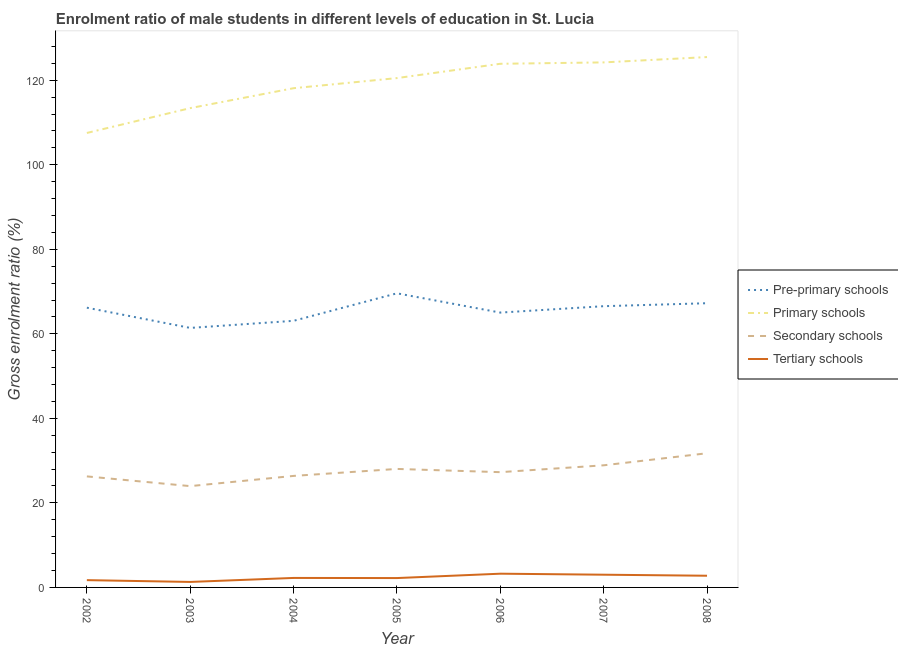Does the line corresponding to gross enrolment ratio(female) in tertiary schools intersect with the line corresponding to gross enrolment ratio(female) in secondary schools?
Your answer should be very brief. No. What is the gross enrolment ratio(female) in pre-primary schools in 2003?
Your answer should be compact. 61.4. Across all years, what is the maximum gross enrolment ratio(female) in primary schools?
Ensure brevity in your answer.  125.48. Across all years, what is the minimum gross enrolment ratio(female) in pre-primary schools?
Your answer should be very brief. 61.4. What is the total gross enrolment ratio(female) in tertiary schools in the graph?
Give a very brief answer. 16.5. What is the difference between the gross enrolment ratio(female) in tertiary schools in 2004 and that in 2006?
Offer a terse response. -1. What is the difference between the gross enrolment ratio(female) in pre-primary schools in 2006 and the gross enrolment ratio(female) in tertiary schools in 2008?
Offer a very short reply. 62.26. What is the average gross enrolment ratio(female) in tertiary schools per year?
Your answer should be very brief. 2.36. In the year 2002, what is the difference between the gross enrolment ratio(female) in secondary schools and gross enrolment ratio(female) in primary schools?
Offer a very short reply. -81.26. In how many years, is the gross enrolment ratio(female) in secondary schools greater than 28 %?
Ensure brevity in your answer.  3. What is the ratio of the gross enrolment ratio(female) in secondary schools in 2005 to that in 2008?
Make the answer very short. 0.88. Is the difference between the gross enrolment ratio(female) in pre-primary schools in 2006 and 2008 greater than the difference between the gross enrolment ratio(female) in tertiary schools in 2006 and 2008?
Your answer should be compact. No. What is the difference between the highest and the second highest gross enrolment ratio(female) in primary schools?
Your response must be concise. 1.26. What is the difference between the highest and the lowest gross enrolment ratio(female) in primary schools?
Your response must be concise. 17.96. Is it the case that in every year, the sum of the gross enrolment ratio(female) in primary schools and gross enrolment ratio(female) in secondary schools is greater than the sum of gross enrolment ratio(female) in pre-primary schools and gross enrolment ratio(female) in tertiary schools?
Give a very brief answer. Yes. Is it the case that in every year, the sum of the gross enrolment ratio(female) in pre-primary schools and gross enrolment ratio(female) in primary schools is greater than the gross enrolment ratio(female) in secondary schools?
Your answer should be very brief. Yes. Does the gross enrolment ratio(female) in tertiary schools monotonically increase over the years?
Your response must be concise. No. Is the gross enrolment ratio(female) in secondary schools strictly greater than the gross enrolment ratio(female) in pre-primary schools over the years?
Your answer should be compact. No. Is the gross enrolment ratio(female) in pre-primary schools strictly less than the gross enrolment ratio(female) in secondary schools over the years?
Make the answer very short. No. What is the difference between two consecutive major ticks on the Y-axis?
Provide a short and direct response. 20. Does the graph contain any zero values?
Give a very brief answer. No. Does the graph contain grids?
Provide a succinct answer. No. How many legend labels are there?
Offer a terse response. 4. How are the legend labels stacked?
Keep it short and to the point. Vertical. What is the title of the graph?
Offer a very short reply. Enrolment ratio of male students in different levels of education in St. Lucia. What is the label or title of the Y-axis?
Your answer should be compact. Gross enrolment ratio (%). What is the Gross enrolment ratio (%) of Pre-primary schools in 2002?
Keep it short and to the point. 66.18. What is the Gross enrolment ratio (%) in Primary schools in 2002?
Your answer should be compact. 107.53. What is the Gross enrolment ratio (%) of Secondary schools in 2002?
Make the answer very short. 26.27. What is the Gross enrolment ratio (%) in Tertiary schools in 2002?
Your response must be concise. 1.72. What is the Gross enrolment ratio (%) in Pre-primary schools in 2003?
Your answer should be very brief. 61.4. What is the Gross enrolment ratio (%) of Primary schools in 2003?
Make the answer very short. 113.4. What is the Gross enrolment ratio (%) in Secondary schools in 2003?
Keep it short and to the point. 23.97. What is the Gross enrolment ratio (%) of Tertiary schools in 2003?
Offer a very short reply. 1.3. What is the Gross enrolment ratio (%) of Pre-primary schools in 2004?
Ensure brevity in your answer.  63.08. What is the Gross enrolment ratio (%) of Primary schools in 2004?
Make the answer very short. 118.12. What is the Gross enrolment ratio (%) in Secondary schools in 2004?
Provide a short and direct response. 26.38. What is the Gross enrolment ratio (%) in Tertiary schools in 2004?
Provide a short and direct response. 2.24. What is the Gross enrolment ratio (%) of Pre-primary schools in 2005?
Keep it short and to the point. 69.59. What is the Gross enrolment ratio (%) of Primary schools in 2005?
Keep it short and to the point. 120.51. What is the Gross enrolment ratio (%) of Secondary schools in 2005?
Provide a succinct answer. 28.04. What is the Gross enrolment ratio (%) in Tertiary schools in 2005?
Ensure brevity in your answer.  2.22. What is the Gross enrolment ratio (%) in Pre-primary schools in 2006?
Offer a terse response. 65.03. What is the Gross enrolment ratio (%) of Primary schools in 2006?
Keep it short and to the point. 123.89. What is the Gross enrolment ratio (%) in Secondary schools in 2006?
Your answer should be very brief. 27.27. What is the Gross enrolment ratio (%) in Tertiary schools in 2006?
Ensure brevity in your answer.  3.25. What is the Gross enrolment ratio (%) of Pre-primary schools in 2007?
Ensure brevity in your answer.  66.54. What is the Gross enrolment ratio (%) in Primary schools in 2007?
Keep it short and to the point. 124.22. What is the Gross enrolment ratio (%) in Secondary schools in 2007?
Your answer should be compact. 28.89. What is the Gross enrolment ratio (%) of Tertiary schools in 2007?
Give a very brief answer. 3.01. What is the Gross enrolment ratio (%) of Pre-primary schools in 2008?
Offer a very short reply. 67.24. What is the Gross enrolment ratio (%) of Primary schools in 2008?
Keep it short and to the point. 125.48. What is the Gross enrolment ratio (%) in Secondary schools in 2008?
Make the answer very short. 31.75. What is the Gross enrolment ratio (%) in Tertiary schools in 2008?
Give a very brief answer. 2.76. Across all years, what is the maximum Gross enrolment ratio (%) in Pre-primary schools?
Keep it short and to the point. 69.59. Across all years, what is the maximum Gross enrolment ratio (%) of Primary schools?
Offer a very short reply. 125.48. Across all years, what is the maximum Gross enrolment ratio (%) in Secondary schools?
Make the answer very short. 31.75. Across all years, what is the maximum Gross enrolment ratio (%) in Tertiary schools?
Ensure brevity in your answer.  3.25. Across all years, what is the minimum Gross enrolment ratio (%) in Pre-primary schools?
Provide a short and direct response. 61.4. Across all years, what is the minimum Gross enrolment ratio (%) of Primary schools?
Provide a short and direct response. 107.53. Across all years, what is the minimum Gross enrolment ratio (%) of Secondary schools?
Provide a succinct answer. 23.97. Across all years, what is the minimum Gross enrolment ratio (%) of Tertiary schools?
Give a very brief answer. 1.3. What is the total Gross enrolment ratio (%) in Pre-primary schools in the graph?
Provide a succinct answer. 459.06. What is the total Gross enrolment ratio (%) of Primary schools in the graph?
Make the answer very short. 833.15. What is the total Gross enrolment ratio (%) of Secondary schools in the graph?
Give a very brief answer. 192.57. What is the total Gross enrolment ratio (%) of Tertiary schools in the graph?
Your answer should be very brief. 16.5. What is the difference between the Gross enrolment ratio (%) in Pre-primary schools in 2002 and that in 2003?
Give a very brief answer. 4.78. What is the difference between the Gross enrolment ratio (%) of Primary schools in 2002 and that in 2003?
Make the answer very short. -5.88. What is the difference between the Gross enrolment ratio (%) of Secondary schools in 2002 and that in 2003?
Keep it short and to the point. 2.3. What is the difference between the Gross enrolment ratio (%) in Tertiary schools in 2002 and that in 2003?
Give a very brief answer. 0.42. What is the difference between the Gross enrolment ratio (%) in Pre-primary schools in 2002 and that in 2004?
Make the answer very short. 3.1. What is the difference between the Gross enrolment ratio (%) of Primary schools in 2002 and that in 2004?
Your answer should be very brief. -10.59. What is the difference between the Gross enrolment ratio (%) of Secondary schools in 2002 and that in 2004?
Make the answer very short. -0.11. What is the difference between the Gross enrolment ratio (%) in Tertiary schools in 2002 and that in 2004?
Your answer should be very brief. -0.52. What is the difference between the Gross enrolment ratio (%) of Pre-primary schools in 2002 and that in 2005?
Ensure brevity in your answer.  -3.4. What is the difference between the Gross enrolment ratio (%) in Primary schools in 2002 and that in 2005?
Offer a very short reply. -12.98. What is the difference between the Gross enrolment ratio (%) in Secondary schools in 2002 and that in 2005?
Make the answer very short. -1.77. What is the difference between the Gross enrolment ratio (%) in Tertiary schools in 2002 and that in 2005?
Give a very brief answer. -0.49. What is the difference between the Gross enrolment ratio (%) of Pre-primary schools in 2002 and that in 2006?
Provide a short and direct response. 1.16. What is the difference between the Gross enrolment ratio (%) in Primary schools in 2002 and that in 2006?
Your answer should be compact. -16.37. What is the difference between the Gross enrolment ratio (%) of Secondary schools in 2002 and that in 2006?
Provide a succinct answer. -1. What is the difference between the Gross enrolment ratio (%) of Tertiary schools in 2002 and that in 2006?
Offer a very short reply. -1.53. What is the difference between the Gross enrolment ratio (%) in Pre-primary schools in 2002 and that in 2007?
Make the answer very short. -0.36. What is the difference between the Gross enrolment ratio (%) in Primary schools in 2002 and that in 2007?
Keep it short and to the point. -16.7. What is the difference between the Gross enrolment ratio (%) of Secondary schools in 2002 and that in 2007?
Your answer should be compact. -2.62. What is the difference between the Gross enrolment ratio (%) of Tertiary schools in 2002 and that in 2007?
Your response must be concise. -1.29. What is the difference between the Gross enrolment ratio (%) of Pre-primary schools in 2002 and that in 2008?
Provide a succinct answer. -1.06. What is the difference between the Gross enrolment ratio (%) of Primary schools in 2002 and that in 2008?
Your response must be concise. -17.96. What is the difference between the Gross enrolment ratio (%) in Secondary schools in 2002 and that in 2008?
Provide a succinct answer. -5.48. What is the difference between the Gross enrolment ratio (%) of Tertiary schools in 2002 and that in 2008?
Your answer should be very brief. -1.04. What is the difference between the Gross enrolment ratio (%) in Pre-primary schools in 2003 and that in 2004?
Offer a terse response. -1.68. What is the difference between the Gross enrolment ratio (%) in Primary schools in 2003 and that in 2004?
Your answer should be very brief. -4.72. What is the difference between the Gross enrolment ratio (%) in Secondary schools in 2003 and that in 2004?
Offer a very short reply. -2.42. What is the difference between the Gross enrolment ratio (%) in Tertiary schools in 2003 and that in 2004?
Provide a succinct answer. -0.95. What is the difference between the Gross enrolment ratio (%) in Pre-primary schools in 2003 and that in 2005?
Your response must be concise. -8.19. What is the difference between the Gross enrolment ratio (%) of Primary schools in 2003 and that in 2005?
Ensure brevity in your answer.  -7.11. What is the difference between the Gross enrolment ratio (%) of Secondary schools in 2003 and that in 2005?
Your response must be concise. -4.07. What is the difference between the Gross enrolment ratio (%) in Tertiary schools in 2003 and that in 2005?
Your answer should be compact. -0.92. What is the difference between the Gross enrolment ratio (%) of Pre-primary schools in 2003 and that in 2006?
Your answer should be compact. -3.63. What is the difference between the Gross enrolment ratio (%) of Primary schools in 2003 and that in 2006?
Offer a very short reply. -10.49. What is the difference between the Gross enrolment ratio (%) in Secondary schools in 2003 and that in 2006?
Ensure brevity in your answer.  -3.3. What is the difference between the Gross enrolment ratio (%) of Tertiary schools in 2003 and that in 2006?
Ensure brevity in your answer.  -1.95. What is the difference between the Gross enrolment ratio (%) in Pre-primary schools in 2003 and that in 2007?
Your response must be concise. -5.14. What is the difference between the Gross enrolment ratio (%) of Primary schools in 2003 and that in 2007?
Provide a succinct answer. -10.82. What is the difference between the Gross enrolment ratio (%) of Secondary schools in 2003 and that in 2007?
Your response must be concise. -4.92. What is the difference between the Gross enrolment ratio (%) in Tertiary schools in 2003 and that in 2007?
Offer a terse response. -1.71. What is the difference between the Gross enrolment ratio (%) of Pre-primary schools in 2003 and that in 2008?
Keep it short and to the point. -5.84. What is the difference between the Gross enrolment ratio (%) of Primary schools in 2003 and that in 2008?
Give a very brief answer. -12.08. What is the difference between the Gross enrolment ratio (%) of Secondary schools in 2003 and that in 2008?
Ensure brevity in your answer.  -7.78. What is the difference between the Gross enrolment ratio (%) in Tertiary schools in 2003 and that in 2008?
Offer a terse response. -1.47. What is the difference between the Gross enrolment ratio (%) in Pre-primary schools in 2004 and that in 2005?
Your response must be concise. -6.51. What is the difference between the Gross enrolment ratio (%) of Primary schools in 2004 and that in 2005?
Make the answer very short. -2.39. What is the difference between the Gross enrolment ratio (%) of Secondary schools in 2004 and that in 2005?
Make the answer very short. -1.65. What is the difference between the Gross enrolment ratio (%) in Tertiary schools in 2004 and that in 2005?
Provide a short and direct response. 0.03. What is the difference between the Gross enrolment ratio (%) of Pre-primary schools in 2004 and that in 2006?
Your answer should be very brief. -1.95. What is the difference between the Gross enrolment ratio (%) in Primary schools in 2004 and that in 2006?
Offer a terse response. -5.78. What is the difference between the Gross enrolment ratio (%) in Secondary schools in 2004 and that in 2006?
Make the answer very short. -0.89. What is the difference between the Gross enrolment ratio (%) of Tertiary schools in 2004 and that in 2006?
Keep it short and to the point. -1. What is the difference between the Gross enrolment ratio (%) of Pre-primary schools in 2004 and that in 2007?
Provide a succinct answer. -3.46. What is the difference between the Gross enrolment ratio (%) of Primary schools in 2004 and that in 2007?
Provide a short and direct response. -6.1. What is the difference between the Gross enrolment ratio (%) in Secondary schools in 2004 and that in 2007?
Your answer should be compact. -2.51. What is the difference between the Gross enrolment ratio (%) in Tertiary schools in 2004 and that in 2007?
Offer a terse response. -0.76. What is the difference between the Gross enrolment ratio (%) in Pre-primary schools in 2004 and that in 2008?
Offer a very short reply. -4.16. What is the difference between the Gross enrolment ratio (%) in Primary schools in 2004 and that in 2008?
Provide a succinct answer. -7.37. What is the difference between the Gross enrolment ratio (%) of Secondary schools in 2004 and that in 2008?
Give a very brief answer. -5.36. What is the difference between the Gross enrolment ratio (%) of Tertiary schools in 2004 and that in 2008?
Ensure brevity in your answer.  -0.52. What is the difference between the Gross enrolment ratio (%) of Pre-primary schools in 2005 and that in 2006?
Your answer should be compact. 4.56. What is the difference between the Gross enrolment ratio (%) of Primary schools in 2005 and that in 2006?
Your answer should be very brief. -3.38. What is the difference between the Gross enrolment ratio (%) of Secondary schools in 2005 and that in 2006?
Keep it short and to the point. 0.76. What is the difference between the Gross enrolment ratio (%) in Tertiary schools in 2005 and that in 2006?
Ensure brevity in your answer.  -1.03. What is the difference between the Gross enrolment ratio (%) of Pre-primary schools in 2005 and that in 2007?
Your answer should be compact. 3.05. What is the difference between the Gross enrolment ratio (%) of Primary schools in 2005 and that in 2007?
Give a very brief answer. -3.71. What is the difference between the Gross enrolment ratio (%) in Secondary schools in 2005 and that in 2007?
Provide a short and direct response. -0.86. What is the difference between the Gross enrolment ratio (%) of Tertiary schools in 2005 and that in 2007?
Your answer should be compact. -0.79. What is the difference between the Gross enrolment ratio (%) of Pre-primary schools in 2005 and that in 2008?
Keep it short and to the point. 2.34. What is the difference between the Gross enrolment ratio (%) of Primary schools in 2005 and that in 2008?
Your answer should be very brief. -4.97. What is the difference between the Gross enrolment ratio (%) of Secondary schools in 2005 and that in 2008?
Ensure brevity in your answer.  -3.71. What is the difference between the Gross enrolment ratio (%) of Tertiary schools in 2005 and that in 2008?
Keep it short and to the point. -0.55. What is the difference between the Gross enrolment ratio (%) of Pre-primary schools in 2006 and that in 2007?
Your response must be concise. -1.51. What is the difference between the Gross enrolment ratio (%) of Primary schools in 2006 and that in 2007?
Your answer should be compact. -0.33. What is the difference between the Gross enrolment ratio (%) in Secondary schools in 2006 and that in 2007?
Your answer should be compact. -1.62. What is the difference between the Gross enrolment ratio (%) of Tertiary schools in 2006 and that in 2007?
Provide a short and direct response. 0.24. What is the difference between the Gross enrolment ratio (%) in Pre-primary schools in 2006 and that in 2008?
Offer a terse response. -2.22. What is the difference between the Gross enrolment ratio (%) in Primary schools in 2006 and that in 2008?
Offer a very short reply. -1.59. What is the difference between the Gross enrolment ratio (%) in Secondary schools in 2006 and that in 2008?
Your answer should be compact. -4.47. What is the difference between the Gross enrolment ratio (%) of Tertiary schools in 2006 and that in 2008?
Make the answer very short. 0.48. What is the difference between the Gross enrolment ratio (%) in Pre-primary schools in 2007 and that in 2008?
Give a very brief answer. -0.7. What is the difference between the Gross enrolment ratio (%) in Primary schools in 2007 and that in 2008?
Your answer should be compact. -1.26. What is the difference between the Gross enrolment ratio (%) of Secondary schools in 2007 and that in 2008?
Your response must be concise. -2.85. What is the difference between the Gross enrolment ratio (%) of Tertiary schools in 2007 and that in 2008?
Provide a short and direct response. 0.24. What is the difference between the Gross enrolment ratio (%) of Pre-primary schools in 2002 and the Gross enrolment ratio (%) of Primary schools in 2003?
Your answer should be very brief. -47.22. What is the difference between the Gross enrolment ratio (%) of Pre-primary schools in 2002 and the Gross enrolment ratio (%) of Secondary schools in 2003?
Your response must be concise. 42.21. What is the difference between the Gross enrolment ratio (%) in Pre-primary schools in 2002 and the Gross enrolment ratio (%) in Tertiary schools in 2003?
Offer a very short reply. 64.88. What is the difference between the Gross enrolment ratio (%) in Primary schools in 2002 and the Gross enrolment ratio (%) in Secondary schools in 2003?
Your answer should be compact. 83.56. What is the difference between the Gross enrolment ratio (%) in Primary schools in 2002 and the Gross enrolment ratio (%) in Tertiary schools in 2003?
Offer a terse response. 106.23. What is the difference between the Gross enrolment ratio (%) of Secondary schools in 2002 and the Gross enrolment ratio (%) of Tertiary schools in 2003?
Your answer should be compact. 24.97. What is the difference between the Gross enrolment ratio (%) of Pre-primary schools in 2002 and the Gross enrolment ratio (%) of Primary schools in 2004?
Provide a succinct answer. -51.93. What is the difference between the Gross enrolment ratio (%) in Pre-primary schools in 2002 and the Gross enrolment ratio (%) in Secondary schools in 2004?
Keep it short and to the point. 39.8. What is the difference between the Gross enrolment ratio (%) in Pre-primary schools in 2002 and the Gross enrolment ratio (%) in Tertiary schools in 2004?
Keep it short and to the point. 63.94. What is the difference between the Gross enrolment ratio (%) in Primary schools in 2002 and the Gross enrolment ratio (%) in Secondary schools in 2004?
Keep it short and to the point. 81.14. What is the difference between the Gross enrolment ratio (%) of Primary schools in 2002 and the Gross enrolment ratio (%) of Tertiary schools in 2004?
Offer a terse response. 105.28. What is the difference between the Gross enrolment ratio (%) in Secondary schools in 2002 and the Gross enrolment ratio (%) in Tertiary schools in 2004?
Keep it short and to the point. 24.03. What is the difference between the Gross enrolment ratio (%) in Pre-primary schools in 2002 and the Gross enrolment ratio (%) in Primary schools in 2005?
Ensure brevity in your answer.  -54.33. What is the difference between the Gross enrolment ratio (%) of Pre-primary schools in 2002 and the Gross enrolment ratio (%) of Secondary schools in 2005?
Give a very brief answer. 38.15. What is the difference between the Gross enrolment ratio (%) of Pre-primary schools in 2002 and the Gross enrolment ratio (%) of Tertiary schools in 2005?
Ensure brevity in your answer.  63.97. What is the difference between the Gross enrolment ratio (%) of Primary schools in 2002 and the Gross enrolment ratio (%) of Secondary schools in 2005?
Your answer should be compact. 79.49. What is the difference between the Gross enrolment ratio (%) in Primary schools in 2002 and the Gross enrolment ratio (%) in Tertiary schools in 2005?
Provide a succinct answer. 105.31. What is the difference between the Gross enrolment ratio (%) in Secondary schools in 2002 and the Gross enrolment ratio (%) in Tertiary schools in 2005?
Keep it short and to the point. 24.05. What is the difference between the Gross enrolment ratio (%) of Pre-primary schools in 2002 and the Gross enrolment ratio (%) of Primary schools in 2006?
Offer a terse response. -57.71. What is the difference between the Gross enrolment ratio (%) in Pre-primary schools in 2002 and the Gross enrolment ratio (%) in Secondary schools in 2006?
Offer a terse response. 38.91. What is the difference between the Gross enrolment ratio (%) of Pre-primary schools in 2002 and the Gross enrolment ratio (%) of Tertiary schools in 2006?
Make the answer very short. 62.93. What is the difference between the Gross enrolment ratio (%) in Primary schools in 2002 and the Gross enrolment ratio (%) in Secondary schools in 2006?
Provide a short and direct response. 80.25. What is the difference between the Gross enrolment ratio (%) of Primary schools in 2002 and the Gross enrolment ratio (%) of Tertiary schools in 2006?
Give a very brief answer. 104.28. What is the difference between the Gross enrolment ratio (%) in Secondary schools in 2002 and the Gross enrolment ratio (%) in Tertiary schools in 2006?
Offer a terse response. 23.02. What is the difference between the Gross enrolment ratio (%) in Pre-primary schools in 2002 and the Gross enrolment ratio (%) in Primary schools in 2007?
Your answer should be compact. -58.04. What is the difference between the Gross enrolment ratio (%) of Pre-primary schools in 2002 and the Gross enrolment ratio (%) of Secondary schools in 2007?
Make the answer very short. 37.29. What is the difference between the Gross enrolment ratio (%) of Pre-primary schools in 2002 and the Gross enrolment ratio (%) of Tertiary schools in 2007?
Ensure brevity in your answer.  63.17. What is the difference between the Gross enrolment ratio (%) of Primary schools in 2002 and the Gross enrolment ratio (%) of Secondary schools in 2007?
Your response must be concise. 78.63. What is the difference between the Gross enrolment ratio (%) in Primary schools in 2002 and the Gross enrolment ratio (%) in Tertiary schools in 2007?
Your answer should be very brief. 104.52. What is the difference between the Gross enrolment ratio (%) of Secondary schools in 2002 and the Gross enrolment ratio (%) of Tertiary schools in 2007?
Your answer should be very brief. 23.26. What is the difference between the Gross enrolment ratio (%) in Pre-primary schools in 2002 and the Gross enrolment ratio (%) in Primary schools in 2008?
Keep it short and to the point. -59.3. What is the difference between the Gross enrolment ratio (%) of Pre-primary schools in 2002 and the Gross enrolment ratio (%) of Secondary schools in 2008?
Your response must be concise. 34.44. What is the difference between the Gross enrolment ratio (%) of Pre-primary schools in 2002 and the Gross enrolment ratio (%) of Tertiary schools in 2008?
Your answer should be compact. 63.42. What is the difference between the Gross enrolment ratio (%) in Primary schools in 2002 and the Gross enrolment ratio (%) in Secondary schools in 2008?
Your answer should be compact. 75.78. What is the difference between the Gross enrolment ratio (%) of Primary schools in 2002 and the Gross enrolment ratio (%) of Tertiary schools in 2008?
Provide a short and direct response. 104.76. What is the difference between the Gross enrolment ratio (%) in Secondary schools in 2002 and the Gross enrolment ratio (%) in Tertiary schools in 2008?
Provide a succinct answer. 23.51. What is the difference between the Gross enrolment ratio (%) of Pre-primary schools in 2003 and the Gross enrolment ratio (%) of Primary schools in 2004?
Keep it short and to the point. -56.72. What is the difference between the Gross enrolment ratio (%) of Pre-primary schools in 2003 and the Gross enrolment ratio (%) of Secondary schools in 2004?
Provide a succinct answer. 35.02. What is the difference between the Gross enrolment ratio (%) of Pre-primary schools in 2003 and the Gross enrolment ratio (%) of Tertiary schools in 2004?
Offer a terse response. 59.16. What is the difference between the Gross enrolment ratio (%) of Primary schools in 2003 and the Gross enrolment ratio (%) of Secondary schools in 2004?
Provide a succinct answer. 87.02. What is the difference between the Gross enrolment ratio (%) in Primary schools in 2003 and the Gross enrolment ratio (%) in Tertiary schools in 2004?
Provide a short and direct response. 111.16. What is the difference between the Gross enrolment ratio (%) in Secondary schools in 2003 and the Gross enrolment ratio (%) in Tertiary schools in 2004?
Ensure brevity in your answer.  21.72. What is the difference between the Gross enrolment ratio (%) in Pre-primary schools in 2003 and the Gross enrolment ratio (%) in Primary schools in 2005?
Offer a terse response. -59.11. What is the difference between the Gross enrolment ratio (%) in Pre-primary schools in 2003 and the Gross enrolment ratio (%) in Secondary schools in 2005?
Make the answer very short. 33.37. What is the difference between the Gross enrolment ratio (%) of Pre-primary schools in 2003 and the Gross enrolment ratio (%) of Tertiary schools in 2005?
Give a very brief answer. 59.19. What is the difference between the Gross enrolment ratio (%) in Primary schools in 2003 and the Gross enrolment ratio (%) in Secondary schools in 2005?
Provide a short and direct response. 85.37. What is the difference between the Gross enrolment ratio (%) of Primary schools in 2003 and the Gross enrolment ratio (%) of Tertiary schools in 2005?
Your response must be concise. 111.19. What is the difference between the Gross enrolment ratio (%) in Secondary schools in 2003 and the Gross enrolment ratio (%) in Tertiary schools in 2005?
Make the answer very short. 21.75. What is the difference between the Gross enrolment ratio (%) of Pre-primary schools in 2003 and the Gross enrolment ratio (%) of Primary schools in 2006?
Give a very brief answer. -62.49. What is the difference between the Gross enrolment ratio (%) in Pre-primary schools in 2003 and the Gross enrolment ratio (%) in Secondary schools in 2006?
Provide a short and direct response. 34.13. What is the difference between the Gross enrolment ratio (%) in Pre-primary schools in 2003 and the Gross enrolment ratio (%) in Tertiary schools in 2006?
Your answer should be very brief. 58.15. What is the difference between the Gross enrolment ratio (%) in Primary schools in 2003 and the Gross enrolment ratio (%) in Secondary schools in 2006?
Provide a succinct answer. 86.13. What is the difference between the Gross enrolment ratio (%) of Primary schools in 2003 and the Gross enrolment ratio (%) of Tertiary schools in 2006?
Provide a succinct answer. 110.15. What is the difference between the Gross enrolment ratio (%) of Secondary schools in 2003 and the Gross enrolment ratio (%) of Tertiary schools in 2006?
Offer a very short reply. 20.72. What is the difference between the Gross enrolment ratio (%) of Pre-primary schools in 2003 and the Gross enrolment ratio (%) of Primary schools in 2007?
Your answer should be compact. -62.82. What is the difference between the Gross enrolment ratio (%) of Pre-primary schools in 2003 and the Gross enrolment ratio (%) of Secondary schools in 2007?
Keep it short and to the point. 32.51. What is the difference between the Gross enrolment ratio (%) of Pre-primary schools in 2003 and the Gross enrolment ratio (%) of Tertiary schools in 2007?
Your response must be concise. 58.39. What is the difference between the Gross enrolment ratio (%) of Primary schools in 2003 and the Gross enrolment ratio (%) of Secondary schools in 2007?
Your answer should be very brief. 84.51. What is the difference between the Gross enrolment ratio (%) in Primary schools in 2003 and the Gross enrolment ratio (%) in Tertiary schools in 2007?
Make the answer very short. 110.39. What is the difference between the Gross enrolment ratio (%) in Secondary schools in 2003 and the Gross enrolment ratio (%) in Tertiary schools in 2007?
Provide a short and direct response. 20.96. What is the difference between the Gross enrolment ratio (%) of Pre-primary schools in 2003 and the Gross enrolment ratio (%) of Primary schools in 2008?
Offer a terse response. -64.08. What is the difference between the Gross enrolment ratio (%) of Pre-primary schools in 2003 and the Gross enrolment ratio (%) of Secondary schools in 2008?
Your response must be concise. 29.65. What is the difference between the Gross enrolment ratio (%) of Pre-primary schools in 2003 and the Gross enrolment ratio (%) of Tertiary schools in 2008?
Make the answer very short. 58.64. What is the difference between the Gross enrolment ratio (%) in Primary schools in 2003 and the Gross enrolment ratio (%) in Secondary schools in 2008?
Provide a short and direct response. 81.65. What is the difference between the Gross enrolment ratio (%) in Primary schools in 2003 and the Gross enrolment ratio (%) in Tertiary schools in 2008?
Provide a short and direct response. 110.64. What is the difference between the Gross enrolment ratio (%) of Secondary schools in 2003 and the Gross enrolment ratio (%) of Tertiary schools in 2008?
Provide a succinct answer. 21.2. What is the difference between the Gross enrolment ratio (%) in Pre-primary schools in 2004 and the Gross enrolment ratio (%) in Primary schools in 2005?
Your answer should be very brief. -57.43. What is the difference between the Gross enrolment ratio (%) of Pre-primary schools in 2004 and the Gross enrolment ratio (%) of Secondary schools in 2005?
Your response must be concise. 35.04. What is the difference between the Gross enrolment ratio (%) of Pre-primary schools in 2004 and the Gross enrolment ratio (%) of Tertiary schools in 2005?
Keep it short and to the point. 60.86. What is the difference between the Gross enrolment ratio (%) in Primary schools in 2004 and the Gross enrolment ratio (%) in Secondary schools in 2005?
Your answer should be compact. 90.08. What is the difference between the Gross enrolment ratio (%) of Primary schools in 2004 and the Gross enrolment ratio (%) of Tertiary schools in 2005?
Offer a terse response. 115.9. What is the difference between the Gross enrolment ratio (%) in Secondary schools in 2004 and the Gross enrolment ratio (%) in Tertiary schools in 2005?
Make the answer very short. 24.17. What is the difference between the Gross enrolment ratio (%) in Pre-primary schools in 2004 and the Gross enrolment ratio (%) in Primary schools in 2006?
Give a very brief answer. -60.81. What is the difference between the Gross enrolment ratio (%) in Pre-primary schools in 2004 and the Gross enrolment ratio (%) in Secondary schools in 2006?
Offer a very short reply. 35.81. What is the difference between the Gross enrolment ratio (%) in Pre-primary schools in 2004 and the Gross enrolment ratio (%) in Tertiary schools in 2006?
Provide a short and direct response. 59.83. What is the difference between the Gross enrolment ratio (%) in Primary schools in 2004 and the Gross enrolment ratio (%) in Secondary schools in 2006?
Your answer should be compact. 90.84. What is the difference between the Gross enrolment ratio (%) of Primary schools in 2004 and the Gross enrolment ratio (%) of Tertiary schools in 2006?
Offer a very short reply. 114.87. What is the difference between the Gross enrolment ratio (%) of Secondary schools in 2004 and the Gross enrolment ratio (%) of Tertiary schools in 2006?
Ensure brevity in your answer.  23.14. What is the difference between the Gross enrolment ratio (%) in Pre-primary schools in 2004 and the Gross enrolment ratio (%) in Primary schools in 2007?
Give a very brief answer. -61.14. What is the difference between the Gross enrolment ratio (%) of Pre-primary schools in 2004 and the Gross enrolment ratio (%) of Secondary schools in 2007?
Your response must be concise. 34.19. What is the difference between the Gross enrolment ratio (%) in Pre-primary schools in 2004 and the Gross enrolment ratio (%) in Tertiary schools in 2007?
Offer a terse response. 60.07. What is the difference between the Gross enrolment ratio (%) of Primary schools in 2004 and the Gross enrolment ratio (%) of Secondary schools in 2007?
Your answer should be compact. 89.22. What is the difference between the Gross enrolment ratio (%) in Primary schools in 2004 and the Gross enrolment ratio (%) in Tertiary schools in 2007?
Your answer should be compact. 115.11. What is the difference between the Gross enrolment ratio (%) of Secondary schools in 2004 and the Gross enrolment ratio (%) of Tertiary schools in 2007?
Your response must be concise. 23.38. What is the difference between the Gross enrolment ratio (%) in Pre-primary schools in 2004 and the Gross enrolment ratio (%) in Primary schools in 2008?
Offer a very short reply. -62.4. What is the difference between the Gross enrolment ratio (%) in Pre-primary schools in 2004 and the Gross enrolment ratio (%) in Secondary schools in 2008?
Your answer should be compact. 31.33. What is the difference between the Gross enrolment ratio (%) in Pre-primary schools in 2004 and the Gross enrolment ratio (%) in Tertiary schools in 2008?
Give a very brief answer. 60.31. What is the difference between the Gross enrolment ratio (%) of Primary schools in 2004 and the Gross enrolment ratio (%) of Secondary schools in 2008?
Make the answer very short. 86.37. What is the difference between the Gross enrolment ratio (%) in Primary schools in 2004 and the Gross enrolment ratio (%) in Tertiary schools in 2008?
Your answer should be compact. 115.35. What is the difference between the Gross enrolment ratio (%) of Secondary schools in 2004 and the Gross enrolment ratio (%) of Tertiary schools in 2008?
Give a very brief answer. 23.62. What is the difference between the Gross enrolment ratio (%) of Pre-primary schools in 2005 and the Gross enrolment ratio (%) of Primary schools in 2006?
Your answer should be very brief. -54.31. What is the difference between the Gross enrolment ratio (%) in Pre-primary schools in 2005 and the Gross enrolment ratio (%) in Secondary schools in 2006?
Offer a terse response. 42.31. What is the difference between the Gross enrolment ratio (%) of Pre-primary schools in 2005 and the Gross enrolment ratio (%) of Tertiary schools in 2006?
Keep it short and to the point. 66.34. What is the difference between the Gross enrolment ratio (%) of Primary schools in 2005 and the Gross enrolment ratio (%) of Secondary schools in 2006?
Keep it short and to the point. 93.24. What is the difference between the Gross enrolment ratio (%) in Primary schools in 2005 and the Gross enrolment ratio (%) in Tertiary schools in 2006?
Ensure brevity in your answer.  117.26. What is the difference between the Gross enrolment ratio (%) in Secondary schools in 2005 and the Gross enrolment ratio (%) in Tertiary schools in 2006?
Give a very brief answer. 24.79. What is the difference between the Gross enrolment ratio (%) in Pre-primary schools in 2005 and the Gross enrolment ratio (%) in Primary schools in 2007?
Provide a short and direct response. -54.63. What is the difference between the Gross enrolment ratio (%) in Pre-primary schools in 2005 and the Gross enrolment ratio (%) in Secondary schools in 2007?
Offer a very short reply. 40.69. What is the difference between the Gross enrolment ratio (%) of Pre-primary schools in 2005 and the Gross enrolment ratio (%) of Tertiary schools in 2007?
Ensure brevity in your answer.  66.58. What is the difference between the Gross enrolment ratio (%) in Primary schools in 2005 and the Gross enrolment ratio (%) in Secondary schools in 2007?
Ensure brevity in your answer.  91.62. What is the difference between the Gross enrolment ratio (%) of Primary schools in 2005 and the Gross enrolment ratio (%) of Tertiary schools in 2007?
Offer a very short reply. 117.5. What is the difference between the Gross enrolment ratio (%) in Secondary schools in 2005 and the Gross enrolment ratio (%) in Tertiary schools in 2007?
Your answer should be very brief. 25.03. What is the difference between the Gross enrolment ratio (%) of Pre-primary schools in 2005 and the Gross enrolment ratio (%) of Primary schools in 2008?
Give a very brief answer. -55.89. What is the difference between the Gross enrolment ratio (%) in Pre-primary schools in 2005 and the Gross enrolment ratio (%) in Secondary schools in 2008?
Offer a very short reply. 37.84. What is the difference between the Gross enrolment ratio (%) in Pre-primary schools in 2005 and the Gross enrolment ratio (%) in Tertiary schools in 2008?
Offer a very short reply. 66.82. What is the difference between the Gross enrolment ratio (%) in Primary schools in 2005 and the Gross enrolment ratio (%) in Secondary schools in 2008?
Your response must be concise. 88.76. What is the difference between the Gross enrolment ratio (%) in Primary schools in 2005 and the Gross enrolment ratio (%) in Tertiary schools in 2008?
Offer a very short reply. 117.74. What is the difference between the Gross enrolment ratio (%) of Secondary schools in 2005 and the Gross enrolment ratio (%) of Tertiary schools in 2008?
Your answer should be very brief. 25.27. What is the difference between the Gross enrolment ratio (%) in Pre-primary schools in 2006 and the Gross enrolment ratio (%) in Primary schools in 2007?
Give a very brief answer. -59.2. What is the difference between the Gross enrolment ratio (%) in Pre-primary schools in 2006 and the Gross enrolment ratio (%) in Secondary schools in 2007?
Ensure brevity in your answer.  36.13. What is the difference between the Gross enrolment ratio (%) in Pre-primary schools in 2006 and the Gross enrolment ratio (%) in Tertiary schools in 2007?
Give a very brief answer. 62.02. What is the difference between the Gross enrolment ratio (%) in Primary schools in 2006 and the Gross enrolment ratio (%) in Secondary schools in 2007?
Offer a terse response. 95. What is the difference between the Gross enrolment ratio (%) of Primary schools in 2006 and the Gross enrolment ratio (%) of Tertiary schools in 2007?
Your answer should be compact. 120.88. What is the difference between the Gross enrolment ratio (%) of Secondary schools in 2006 and the Gross enrolment ratio (%) of Tertiary schools in 2007?
Provide a short and direct response. 24.26. What is the difference between the Gross enrolment ratio (%) of Pre-primary schools in 2006 and the Gross enrolment ratio (%) of Primary schools in 2008?
Ensure brevity in your answer.  -60.46. What is the difference between the Gross enrolment ratio (%) in Pre-primary schools in 2006 and the Gross enrolment ratio (%) in Secondary schools in 2008?
Keep it short and to the point. 33.28. What is the difference between the Gross enrolment ratio (%) of Pre-primary schools in 2006 and the Gross enrolment ratio (%) of Tertiary schools in 2008?
Give a very brief answer. 62.26. What is the difference between the Gross enrolment ratio (%) of Primary schools in 2006 and the Gross enrolment ratio (%) of Secondary schools in 2008?
Ensure brevity in your answer.  92.15. What is the difference between the Gross enrolment ratio (%) of Primary schools in 2006 and the Gross enrolment ratio (%) of Tertiary schools in 2008?
Keep it short and to the point. 121.13. What is the difference between the Gross enrolment ratio (%) of Secondary schools in 2006 and the Gross enrolment ratio (%) of Tertiary schools in 2008?
Provide a short and direct response. 24.51. What is the difference between the Gross enrolment ratio (%) of Pre-primary schools in 2007 and the Gross enrolment ratio (%) of Primary schools in 2008?
Offer a terse response. -58.94. What is the difference between the Gross enrolment ratio (%) in Pre-primary schools in 2007 and the Gross enrolment ratio (%) in Secondary schools in 2008?
Provide a succinct answer. 34.79. What is the difference between the Gross enrolment ratio (%) of Pre-primary schools in 2007 and the Gross enrolment ratio (%) of Tertiary schools in 2008?
Make the answer very short. 63.77. What is the difference between the Gross enrolment ratio (%) in Primary schools in 2007 and the Gross enrolment ratio (%) in Secondary schools in 2008?
Your answer should be very brief. 92.47. What is the difference between the Gross enrolment ratio (%) of Primary schools in 2007 and the Gross enrolment ratio (%) of Tertiary schools in 2008?
Offer a terse response. 121.46. What is the difference between the Gross enrolment ratio (%) of Secondary schools in 2007 and the Gross enrolment ratio (%) of Tertiary schools in 2008?
Keep it short and to the point. 26.13. What is the average Gross enrolment ratio (%) in Pre-primary schools per year?
Give a very brief answer. 65.58. What is the average Gross enrolment ratio (%) of Primary schools per year?
Provide a short and direct response. 119.02. What is the average Gross enrolment ratio (%) in Secondary schools per year?
Make the answer very short. 27.51. What is the average Gross enrolment ratio (%) of Tertiary schools per year?
Offer a terse response. 2.36. In the year 2002, what is the difference between the Gross enrolment ratio (%) of Pre-primary schools and Gross enrolment ratio (%) of Primary schools?
Keep it short and to the point. -41.34. In the year 2002, what is the difference between the Gross enrolment ratio (%) of Pre-primary schools and Gross enrolment ratio (%) of Secondary schools?
Your answer should be very brief. 39.91. In the year 2002, what is the difference between the Gross enrolment ratio (%) of Pre-primary schools and Gross enrolment ratio (%) of Tertiary schools?
Provide a succinct answer. 64.46. In the year 2002, what is the difference between the Gross enrolment ratio (%) in Primary schools and Gross enrolment ratio (%) in Secondary schools?
Keep it short and to the point. 81.26. In the year 2002, what is the difference between the Gross enrolment ratio (%) in Primary schools and Gross enrolment ratio (%) in Tertiary schools?
Your answer should be compact. 105.8. In the year 2002, what is the difference between the Gross enrolment ratio (%) in Secondary schools and Gross enrolment ratio (%) in Tertiary schools?
Your response must be concise. 24.55. In the year 2003, what is the difference between the Gross enrolment ratio (%) of Pre-primary schools and Gross enrolment ratio (%) of Primary schools?
Provide a short and direct response. -52. In the year 2003, what is the difference between the Gross enrolment ratio (%) of Pre-primary schools and Gross enrolment ratio (%) of Secondary schools?
Keep it short and to the point. 37.43. In the year 2003, what is the difference between the Gross enrolment ratio (%) of Pre-primary schools and Gross enrolment ratio (%) of Tertiary schools?
Your answer should be very brief. 60.1. In the year 2003, what is the difference between the Gross enrolment ratio (%) in Primary schools and Gross enrolment ratio (%) in Secondary schools?
Offer a terse response. 89.43. In the year 2003, what is the difference between the Gross enrolment ratio (%) in Primary schools and Gross enrolment ratio (%) in Tertiary schools?
Provide a short and direct response. 112.1. In the year 2003, what is the difference between the Gross enrolment ratio (%) in Secondary schools and Gross enrolment ratio (%) in Tertiary schools?
Your answer should be very brief. 22.67. In the year 2004, what is the difference between the Gross enrolment ratio (%) in Pre-primary schools and Gross enrolment ratio (%) in Primary schools?
Make the answer very short. -55.04. In the year 2004, what is the difference between the Gross enrolment ratio (%) of Pre-primary schools and Gross enrolment ratio (%) of Secondary schools?
Make the answer very short. 36.69. In the year 2004, what is the difference between the Gross enrolment ratio (%) in Pre-primary schools and Gross enrolment ratio (%) in Tertiary schools?
Offer a very short reply. 60.83. In the year 2004, what is the difference between the Gross enrolment ratio (%) of Primary schools and Gross enrolment ratio (%) of Secondary schools?
Provide a short and direct response. 91.73. In the year 2004, what is the difference between the Gross enrolment ratio (%) of Primary schools and Gross enrolment ratio (%) of Tertiary schools?
Give a very brief answer. 115.87. In the year 2004, what is the difference between the Gross enrolment ratio (%) in Secondary schools and Gross enrolment ratio (%) in Tertiary schools?
Ensure brevity in your answer.  24.14. In the year 2005, what is the difference between the Gross enrolment ratio (%) in Pre-primary schools and Gross enrolment ratio (%) in Primary schools?
Keep it short and to the point. -50.92. In the year 2005, what is the difference between the Gross enrolment ratio (%) of Pre-primary schools and Gross enrolment ratio (%) of Secondary schools?
Keep it short and to the point. 41.55. In the year 2005, what is the difference between the Gross enrolment ratio (%) of Pre-primary schools and Gross enrolment ratio (%) of Tertiary schools?
Give a very brief answer. 67.37. In the year 2005, what is the difference between the Gross enrolment ratio (%) of Primary schools and Gross enrolment ratio (%) of Secondary schools?
Offer a very short reply. 92.47. In the year 2005, what is the difference between the Gross enrolment ratio (%) in Primary schools and Gross enrolment ratio (%) in Tertiary schools?
Keep it short and to the point. 118.29. In the year 2005, what is the difference between the Gross enrolment ratio (%) of Secondary schools and Gross enrolment ratio (%) of Tertiary schools?
Keep it short and to the point. 25.82. In the year 2006, what is the difference between the Gross enrolment ratio (%) in Pre-primary schools and Gross enrolment ratio (%) in Primary schools?
Offer a terse response. -58.87. In the year 2006, what is the difference between the Gross enrolment ratio (%) of Pre-primary schools and Gross enrolment ratio (%) of Secondary schools?
Keep it short and to the point. 37.75. In the year 2006, what is the difference between the Gross enrolment ratio (%) of Pre-primary schools and Gross enrolment ratio (%) of Tertiary schools?
Ensure brevity in your answer.  61.78. In the year 2006, what is the difference between the Gross enrolment ratio (%) of Primary schools and Gross enrolment ratio (%) of Secondary schools?
Make the answer very short. 96.62. In the year 2006, what is the difference between the Gross enrolment ratio (%) in Primary schools and Gross enrolment ratio (%) in Tertiary schools?
Your answer should be very brief. 120.64. In the year 2006, what is the difference between the Gross enrolment ratio (%) in Secondary schools and Gross enrolment ratio (%) in Tertiary schools?
Keep it short and to the point. 24.02. In the year 2007, what is the difference between the Gross enrolment ratio (%) of Pre-primary schools and Gross enrolment ratio (%) of Primary schools?
Offer a very short reply. -57.68. In the year 2007, what is the difference between the Gross enrolment ratio (%) in Pre-primary schools and Gross enrolment ratio (%) in Secondary schools?
Your response must be concise. 37.65. In the year 2007, what is the difference between the Gross enrolment ratio (%) of Pre-primary schools and Gross enrolment ratio (%) of Tertiary schools?
Provide a short and direct response. 63.53. In the year 2007, what is the difference between the Gross enrolment ratio (%) of Primary schools and Gross enrolment ratio (%) of Secondary schools?
Make the answer very short. 95.33. In the year 2007, what is the difference between the Gross enrolment ratio (%) of Primary schools and Gross enrolment ratio (%) of Tertiary schools?
Your answer should be very brief. 121.21. In the year 2007, what is the difference between the Gross enrolment ratio (%) of Secondary schools and Gross enrolment ratio (%) of Tertiary schools?
Ensure brevity in your answer.  25.88. In the year 2008, what is the difference between the Gross enrolment ratio (%) of Pre-primary schools and Gross enrolment ratio (%) of Primary schools?
Make the answer very short. -58.24. In the year 2008, what is the difference between the Gross enrolment ratio (%) in Pre-primary schools and Gross enrolment ratio (%) in Secondary schools?
Make the answer very short. 35.5. In the year 2008, what is the difference between the Gross enrolment ratio (%) in Pre-primary schools and Gross enrolment ratio (%) in Tertiary schools?
Offer a terse response. 64.48. In the year 2008, what is the difference between the Gross enrolment ratio (%) in Primary schools and Gross enrolment ratio (%) in Secondary schools?
Your response must be concise. 93.74. In the year 2008, what is the difference between the Gross enrolment ratio (%) in Primary schools and Gross enrolment ratio (%) in Tertiary schools?
Keep it short and to the point. 122.72. In the year 2008, what is the difference between the Gross enrolment ratio (%) of Secondary schools and Gross enrolment ratio (%) of Tertiary schools?
Provide a succinct answer. 28.98. What is the ratio of the Gross enrolment ratio (%) in Pre-primary schools in 2002 to that in 2003?
Your answer should be compact. 1.08. What is the ratio of the Gross enrolment ratio (%) of Primary schools in 2002 to that in 2003?
Give a very brief answer. 0.95. What is the ratio of the Gross enrolment ratio (%) in Secondary schools in 2002 to that in 2003?
Your response must be concise. 1.1. What is the ratio of the Gross enrolment ratio (%) in Tertiary schools in 2002 to that in 2003?
Provide a short and direct response. 1.33. What is the ratio of the Gross enrolment ratio (%) of Pre-primary schools in 2002 to that in 2004?
Offer a very short reply. 1.05. What is the ratio of the Gross enrolment ratio (%) in Primary schools in 2002 to that in 2004?
Provide a succinct answer. 0.91. What is the ratio of the Gross enrolment ratio (%) in Tertiary schools in 2002 to that in 2004?
Ensure brevity in your answer.  0.77. What is the ratio of the Gross enrolment ratio (%) of Pre-primary schools in 2002 to that in 2005?
Make the answer very short. 0.95. What is the ratio of the Gross enrolment ratio (%) of Primary schools in 2002 to that in 2005?
Your response must be concise. 0.89. What is the ratio of the Gross enrolment ratio (%) of Secondary schools in 2002 to that in 2005?
Your response must be concise. 0.94. What is the ratio of the Gross enrolment ratio (%) in Tertiary schools in 2002 to that in 2005?
Keep it short and to the point. 0.78. What is the ratio of the Gross enrolment ratio (%) in Pre-primary schools in 2002 to that in 2006?
Your response must be concise. 1.02. What is the ratio of the Gross enrolment ratio (%) of Primary schools in 2002 to that in 2006?
Your answer should be compact. 0.87. What is the ratio of the Gross enrolment ratio (%) in Secondary schools in 2002 to that in 2006?
Give a very brief answer. 0.96. What is the ratio of the Gross enrolment ratio (%) of Tertiary schools in 2002 to that in 2006?
Offer a very short reply. 0.53. What is the ratio of the Gross enrolment ratio (%) of Pre-primary schools in 2002 to that in 2007?
Offer a very short reply. 0.99. What is the ratio of the Gross enrolment ratio (%) in Primary schools in 2002 to that in 2007?
Give a very brief answer. 0.87. What is the ratio of the Gross enrolment ratio (%) of Secondary schools in 2002 to that in 2007?
Provide a succinct answer. 0.91. What is the ratio of the Gross enrolment ratio (%) of Tertiary schools in 2002 to that in 2007?
Provide a succinct answer. 0.57. What is the ratio of the Gross enrolment ratio (%) in Pre-primary schools in 2002 to that in 2008?
Make the answer very short. 0.98. What is the ratio of the Gross enrolment ratio (%) of Primary schools in 2002 to that in 2008?
Offer a terse response. 0.86. What is the ratio of the Gross enrolment ratio (%) in Secondary schools in 2002 to that in 2008?
Keep it short and to the point. 0.83. What is the ratio of the Gross enrolment ratio (%) in Tertiary schools in 2002 to that in 2008?
Provide a short and direct response. 0.62. What is the ratio of the Gross enrolment ratio (%) of Pre-primary schools in 2003 to that in 2004?
Offer a very short reply. 0.97. What is the ratio of the Gross enrolment ratio (%) in Primary schools in 2003 to that in 2004?
Offer a very short reply. 0.96. What is the ratio of the Gross enrolment ratio (%) in Secondary schools in 2003 to that in 2004?
Ensure brevity in your answer.  0.91. What is the ratio of the Gross enrolment ratio (%) of Tertiary schools in 2003 to that in 2004?
Keep it short and to the point. 0.58. What is the ratio of the Gross enrolment ratio (%) of Pre-primary schools in 2003 to that in 2005?
Give a very brief answer. 0.88. What is the ratio of the Gross enrolment ratio (%) in Primary schools in 2003 to that in 2005?
Keep it short and to the point. 0.94. What is the ratio of the Gross enrolment ratio (%) in Secondary schools in 2003 to that in 2005?
Your answer should be compact. 0.85. What is the ratio of the Gross enrolment ratio (%) in Tertiary schools in 2003 to that in 2005?
Your response must be concise. 0.59. What is the ratio of the Gross enrolment ratio (%) of Pre-primary schools in 2003 to that in 2006?
Give a very brief answer. 0.94. What is the ratio of the Gross enrolment ratio (%) of Primary schools in 2003 to that in 2006?
Provide a short and direct response. 0.92. What is the ratio of the Gross enrolment ratio (%) in Secondary schools in 2003 to that in 2006?
Offer a very short reply. 0.88. What is the ratio of the Gross enrolment ratio (%) of Tertiary schools in 2003 to that in 2006?
Offer a terse response. 0.4. What is the ratio of the Gross enrolment ratio (%) in Pre-primary schools in 2003 to that in 2007?
Provide a short and direct response. 0.92. What is the ratio of the Gross enrolment ratio (%) in Primary schools in 2003 to that in 2007?
Offer a very short reply. 0.91. What is the ratio of the Gross enrolment ratio (%) in Secondary schools in 2003 to that in 2007?
Your response must be concise. 0.83. What is the ratio of the Gross enrolment ratio (%) in Tertiary schools in 2003 to that in 2007?
Your answer should be compact. 0.43. What is the ratio of the Gross enrolment ratio (%) in Pre-primary schools in 2003 to that in 2008?
Keep it short and to the point. 0.91. What is the ratio of the Gross enrolment ratio (%) in Primary schools in 2003 to that in 2008?
Your answer should be compact. 0.9. What is the ratio of the Gross enrolment ratio (%) of Secondary schools in 2003 to that in 2008?
Your response must be concise. 0.76. What is the ratio of the Gross enrolment ratio (%) of Tertiary schools in 2003 to that in 2008?
Give a very brief answer. 0.47. What is the ratio of the Gross enrolment ratio (%) of Pre-primary schools in 2004 to that in 2005?
Make the answer very short. 0.91. What is the ratio of the Gross enrolment ratio (%) of Primary schools in 2004 to that in 2005?
Your answer should be very brief. 0.98. What is the ratio of the Gross enrolment ratio (%) in Secondary schools in 2004 to that in 2005?
Give a very brief answer. 0.94. What is the ratio of the Gross enrolment ratio (%) of Tertiary schools in 2004 to that in 2005?
Your response must be concise. 1.01. What is the ratio of the Gross enrolment ratio (%) of Pre-primary schools in 2004 to that in 2006?
Ensure brevity in your answer.  0.97. What is the ratio of the Gross enrolment ratio (%) of Primary schools in 2004 to that in 2006?
Offer a terse response. 0.95. What is the ratio of the Gross enrolment ratio (%) of Secondary schools in 2004 to that in 2006?
Provide a succinct answer. 0.97. What is the ratio of the Gross enrolment ratio (%) of Tertiary schools in 2004 to that in 2006?
Your answer should be compact. 0.69. What is the ratio of the Gross enrolment ratio (%) in Pre-primary schools in 2004 to that in 2007?
Your response must be concise. 0.95. What is the ratio of the Gross enrolment ratio (%) of Primary schools in 2004 to that in 2007?
Keep it short and to the point. 0.95. What is the ratio of the Gross enrolment ratio (%) of Secondary schools in 2004 to that in 2007?
Ensure brevity in your answer.  0.91. What is the ratio of the Gross enrolment ratio (%) in Tertiary schools in 2004 to that in 2007?
Offer a very short reply. 0.75. What is the ratio of the Gross enrolment ratio (%) in Pre-primary schools in 2004 to that in 2008?
Your answer should be compact. 0.94. What is the ratio of the Gross enrolment ratio (%) of Primary schools in 2004 to that in 2008?
Keep it short and to the point. 0.94. What is the ratio of the Gross enrolment ratio (%) in Secondary schools in 2004 to that in 2008?
Give a very brief answer. 0.83. What is the ratio of the Gross enrolment ratio (%) in Tertiary schools in 2004 to that in 2008?
Your answer should be compact. 0.81. What is the ratio of the Gross enrolment ratio (%) in Pre-primary schools in 2005 to that in 2006?
Give a very brief answer. 1.07. What is the ratio of the Gross enrolment ratio (%) in Primary schools in 2005 to that in 2006?
Make the answer very short. 0.97. What is the ratio of the Gross enrolment ratio (%) in Secondary schools in 2005 to that in 2006?
Give a very brief answer. 1.03. What is the ratio of the Gross enrolment ratio (%) of Tertiary schools in 2005 to that in 2006?
Make the answer very short. 0.68. What is the ratio of the Gross enrolment ratio (%) in Pre-primary schools in 2005 to that in 2007?
Provide a short and direct response. 1.05. What is the ratio of the Gross enrolment ratio (%) of Primary schools in 2005 to that in 2007?
Ensure brevity in your answer.  0.97. What is the ratio of the Gross enrolment ratio (%) of Secondary schools in 2005 to that in 2007?
Ensure brevity in your answer.  0.97. What is the ratio of the Gross enrolment ratio (%) of Tertiary schools in 2005 to that in 2007?
Keep it short and to the point. 0.74. What is the ratio of the Gross enrolment ratio (%) of Pre-primary schools in 2005 to that in 2008?
Ensure brevity in your answer.  1.03. What is the ratio of the Gross enrolment ratio (%) in Primary schools in 2005 to that in 2008?
Make the answer very short. 0.96. What is the ratio of the Gross enrolment ratio (%) of Secondary schools in 2005 to that in 2008?
Ensure brevity in your answer.  0.88. What is the ratio of the Gross enrolment ratio (%) of Tertiary schools in 2005 to that in 2008?
Keep it short and to the point. 0.8. What is the ratio of the Gross enrolment ratio (%) of Pre-primary schools in 2006 to that in 2007?
Provide a short and direct response. 0.98. What is the ratio of the Gross enrolment ratio (%) of Secondary schools in 2006 to that in 2007?
Your answer should be very brief. 0.94. What is the ratio of the Gross enrolment ratio (%) of Tertiary schools in 2006 to that in 2007?
Ensure brevity in your answer.  1.08. What is the ratio of the Gross enrolment ratio (%) in Pre-primary schools in 2006 to that in 2008?
Your answer should be very brief. 0.97. What is the ratio of the Gross enrolment ratio (%) of Primary schools in 2006 to that in 2008?
Give a very brief answer. 0.99. What is the ratio of the Gross enrolment ratio (%) of Secondary schools in 2006 to that in 2008?
Your answer should be compact. 0.86. What is the ratio of the Gross enrolment ratio (%) of Tertiary schools in 2006 to that in 2008?
Offer a terse response. 1.18. What is the ratio of the Gross enrolment ratio (%) of Primary schools in 2007 to that in 2008?
Make the answer very short. 0.99. What is the ratio of the Gross enrolment ratio (%) of Secondary schools in 2007 to that in 2008?
Provide a short and direct response. 0.91. What is the ratio of the Gross enrolment ratio (%) of Tertiary schools in 2007 to that in 2008?
Keep it short and to the point. 1.09. What is the difference between the highest and the second highest Gross enrolment ratio (%) of Pre-primary schools?
Make the answer very short. 2.34. What is the difference between the highest and the second highest Gross enrolment ratio (%) in Primary schools?
Provide a short and direct response. 1.26. What is the difference between the highest and the second highest Gross enrolment ratio (%) in Secondary schools?
Provide a short and direct response. 2.85. What is the difference between the highest and the second highest Gross enrolment ratio (%) of Tertiary schools?
Offer a very short reply. 0.24. What is the difference between the highest and the lowest Gross enrolment ratio (%) of Pre-primary schools?
Your answer should be very brief. 8.19. What is the difference between the highest and the lowest Gross enrolment ratio (%) of Primary schools?
Keep it short and to the point. 17.96. What is the difference between the highest and the lowest Gross enrolment ratio (%) of Secondary schools?
Offer a very short reply. 7.78. What is the difference between the highest and the lowest Gross enrolment ratio (%) of Tertiary schools?
Provide a succinct answer. 1.95. 